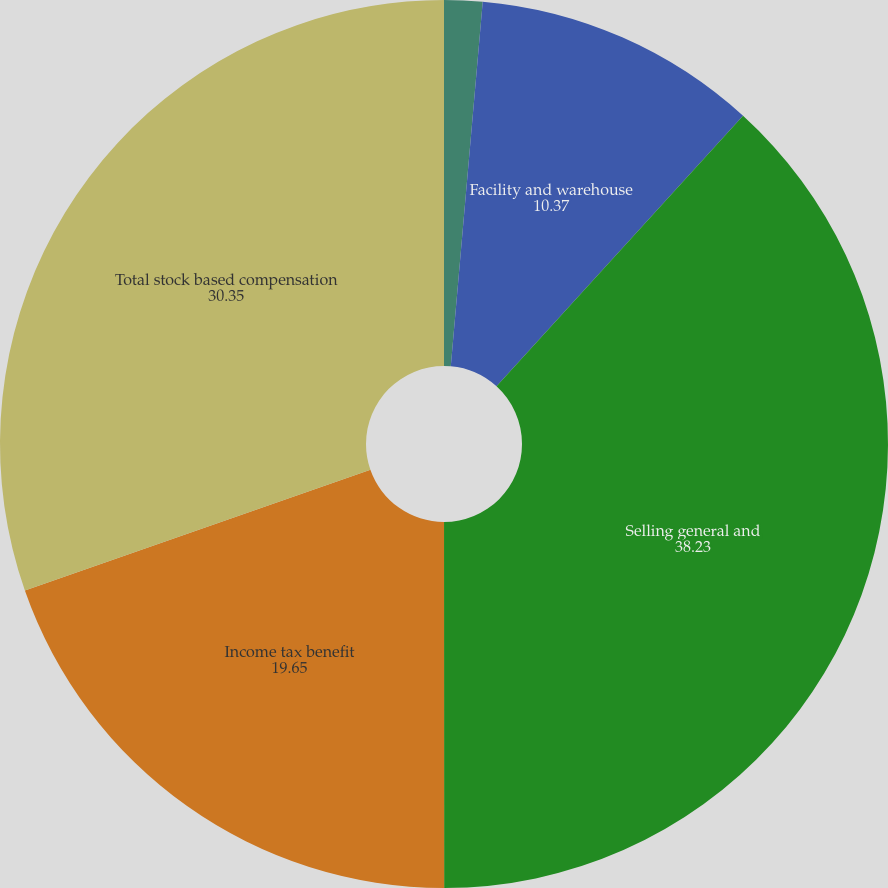Convert chart to OTSL. <chart><loc_0><loc_0><loc_500><loc_500><pie_chart><fcel>Cost of goods sold<fcel>Facility and warehouse<fcel>Selling general and<fcel>Income tax benefit<fcel>Total stock based compensation<nl><fcel>1.39%<fcel>10.37%<fcel>38.23%<fcel>19.65%<fcel>30.35%<nl></chart> 